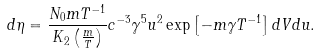Convert formula to latex. <formula><loc_0><loc_0><loc_500><loc_500>d \eta = \frac { N _ { 0 } m T ^ { - 1 } } { K _ { 2 } \left ( \frac { m } { T } \right ) } c ^ { - 3 } \gamma ^ { 5 } u ^ { 2 } \exp \left [ - m \gamma T ^ { - 1 } \right ] d V d u .</formula> 